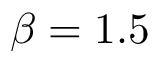Convert formula to latex. <formula><loc_0><loc_0><loc_500><loc_500>\beta = 1 . 5</formula> 